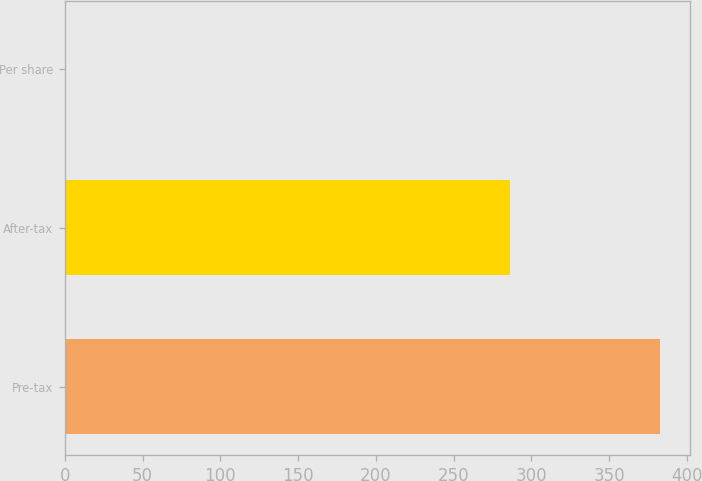Convert chart. <chart><loc_0><loc_0><loc_500><loc_500><bar_chart><fcel>Pre-tax<fcel>After-tax<fcel>Per share<nl><fcel>383<fcel>286<fcel>0.18<nl></chart> 